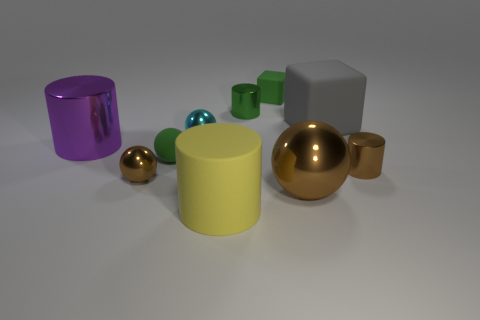Subtract all cylinders. How many objects are left? 6 Subtract 1 purple cylinders. How many objects are left? 9 Subtract all big purple metallic objects. Subtract all large things. How many objects are left? 5 Add 8 brown shiny spheres. How many brown shiny spheres are left? 10 Add 3 cubes. How many cubes exist? 5 